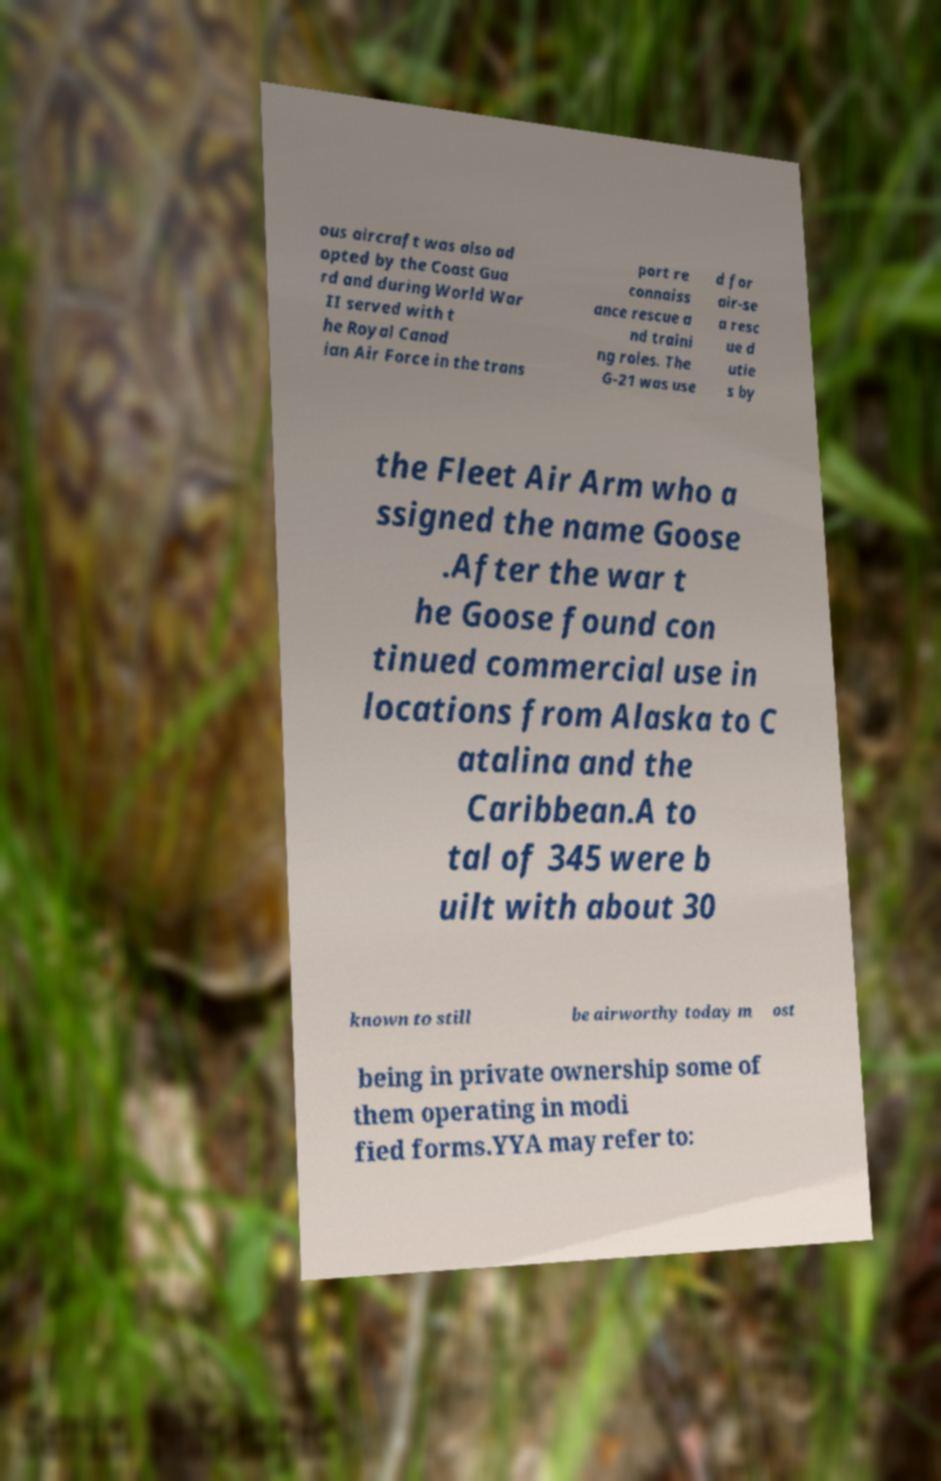I need the written content from this picture converted into text. Can you do that? ous aircraft was also ad opted by the Coast Gua rd and during World War II served with t he Royal Canad ian Air Force in the trans port re connaiss ance rescue a nd traini ng roles. The G-21 was use d for air-se a resc ue d utie s by the Fleet Air Arm who a ssigned the name Goose .After the war t he Goose found con tinued commercial use in locations from Alaska to C atalina and the Caribbean.A to tal of 345 were b uilt with about 30 known to still be airworthy today m ost being in private ownership some of them operating in modi fied forms.YYA may refer to: 